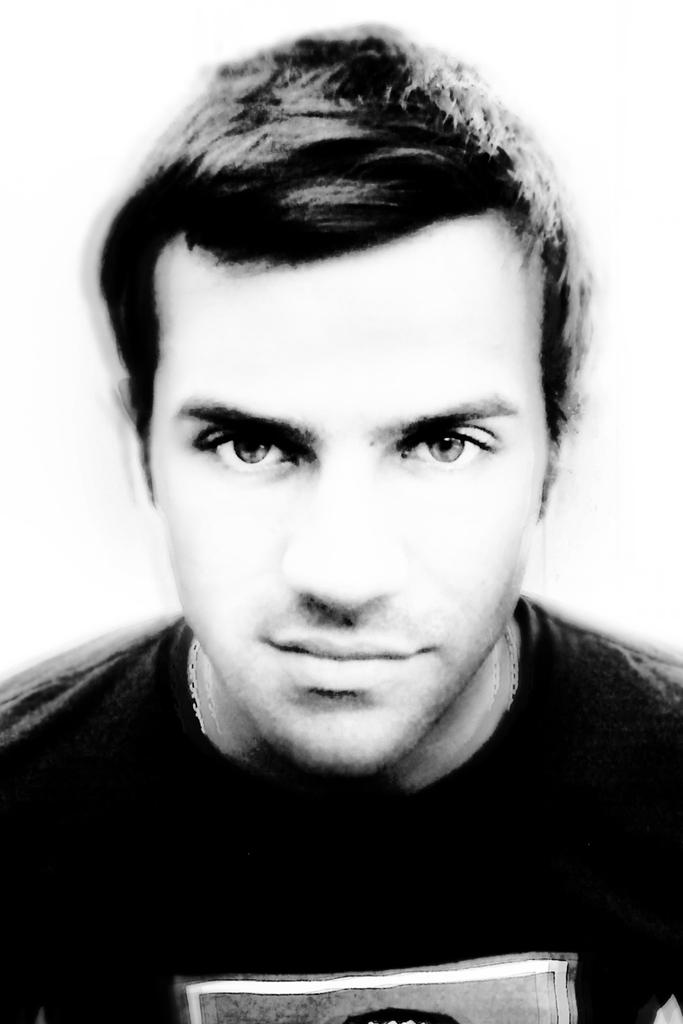What is the color scheme of the image? The image is black and white. Can you describe the main subject in the image? There is a person in the image. What is the person wearing? The person is wearing a T-shirt. What color is the background of the image? The background of the image is white in color. How many fingers does the person have on the floor in the image? There is no person with fingers on the floor in the image, as the image is black and white and only shows a person wearing a T-shirt against a white background. 